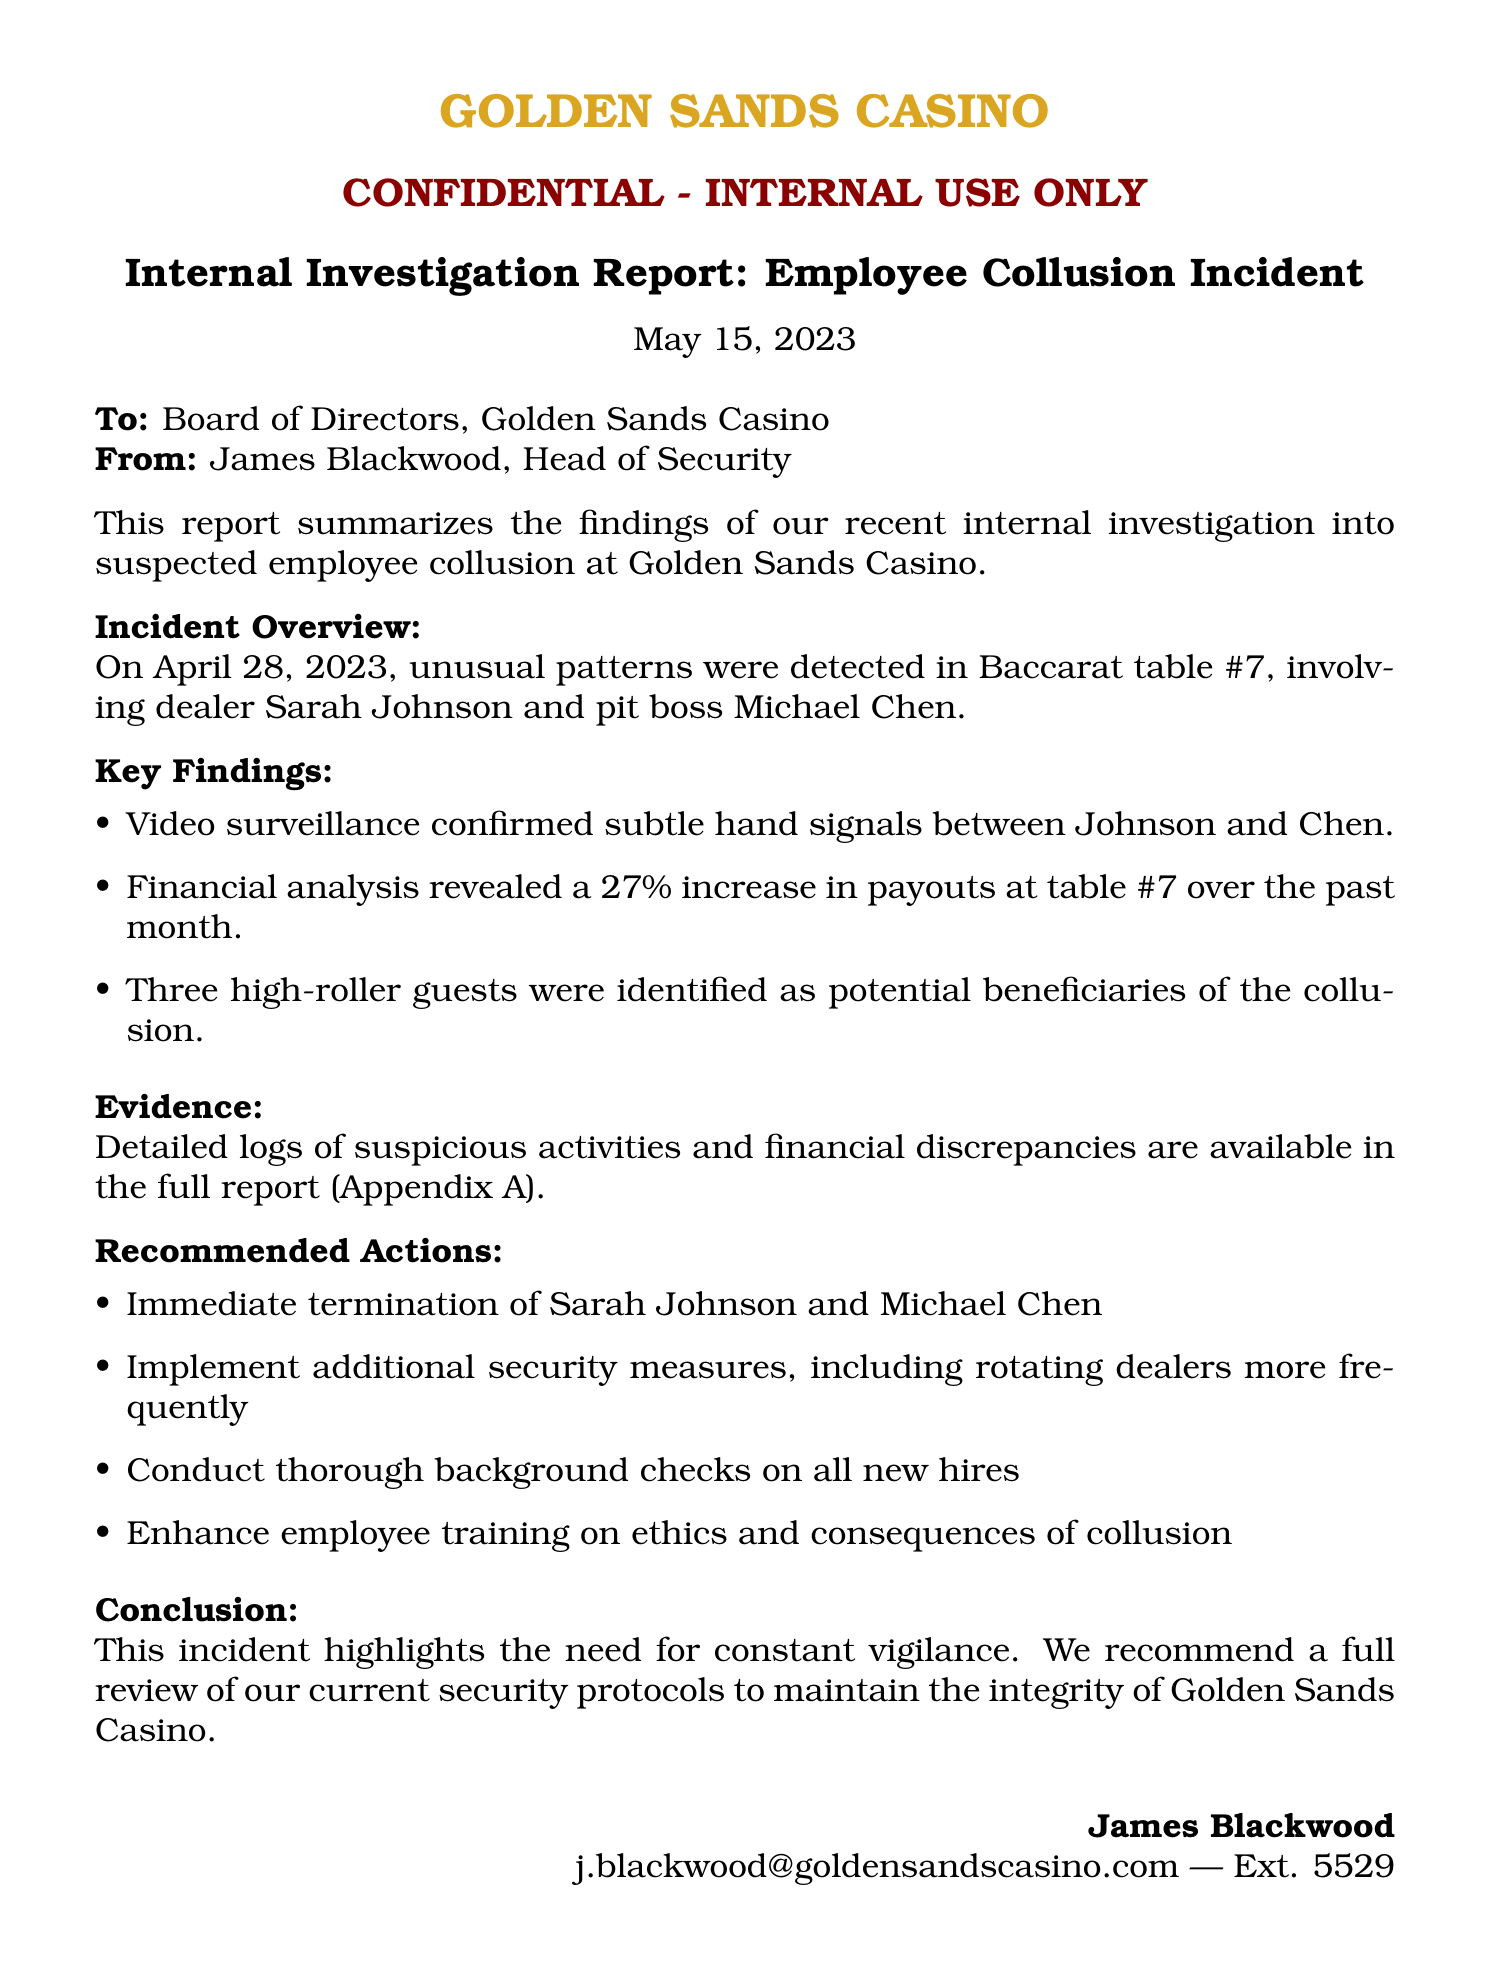What is the incident date? The incident occurred on April 28, 2023, as stated in the document.
Answer: April 28, 2023 Who are the involved parties? The document mentions Sarah Johnson and Michael Chen as the individuals involved in the incident.
Answer: Sarah Johnson and Michael Chen What percentage increase in payouts was observed? The financial analysis section states there was a 27% increase in payouts.
Answer: 27% What are the recommended actions regarding the involved employees? The document specifies immediate termination of Sarah Johnson and Michael Chen as a recommended action.
Answer: Immediate termination What is the purpose of this report? The report summarizes findings from an internal investigation into a suspected employee collusion incident.
Answer: Internal investigation What security measure is suggested to prevent future incidents? The report recommends implementing additional security measures, including rotating dealers more frequently.
Answer: Rotating dealers more frequently What is highlighted as a necessity in the conclusion? The conclusion emphasizes the need for constant vigilance to maintain integrity.
Answer: Constant vigilance Who authored the report? The report is authored by James Blackwood, Head of Security.
Answer: James Blackwood 